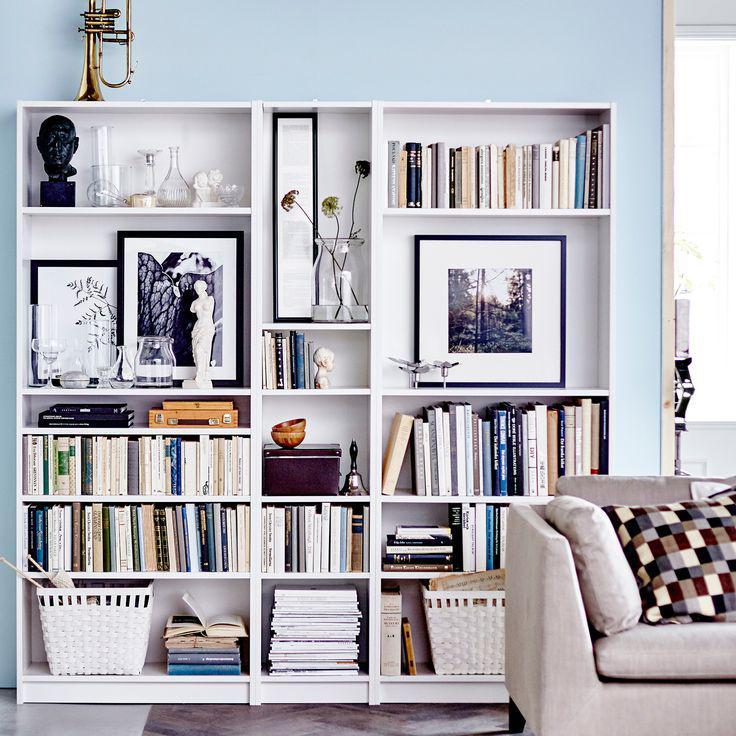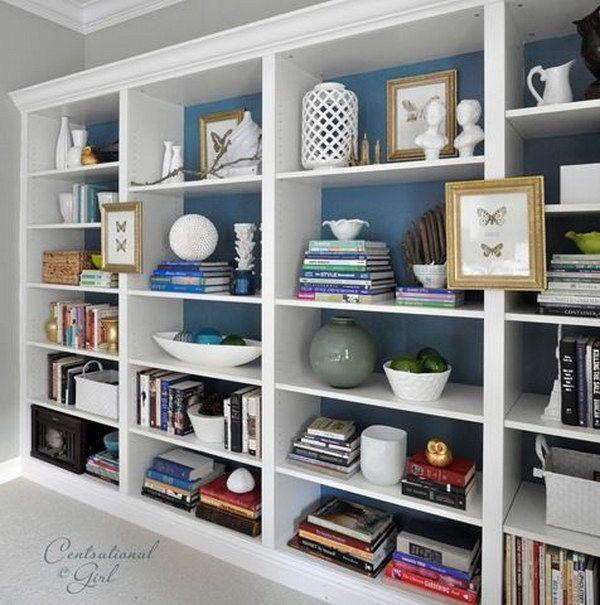The first image is the image on the left, the second image is the image on the right. Assess this claim about the two images: "Seating furniture is visible in front of a bookcase in one image.". Correct or not? Answer yes or no. Yes. 